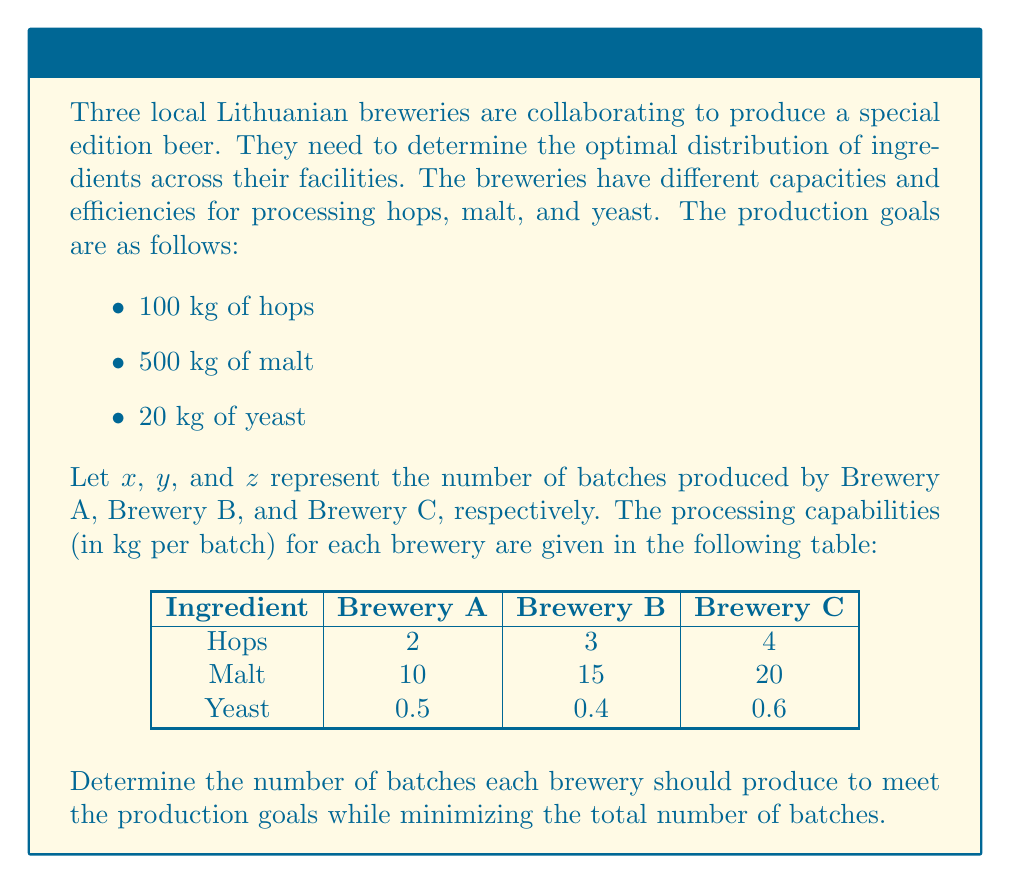Can you solve this math problem? To solve this problem, we need to set up a system of linear equations based on the given information and then solve it.

Step 1: Set up the system of linear equations

For hops: $2x + 3y + 4z = 100$
For malt: $10x + 15y + 20z = 500$
For yeast: $0.5x + 0.4y + 0.6z = 20$

Step 2: Simplify the equations

Equation 1: $2x + 3y + 4z = 100$
Equation 2: $2x + 3y + 4z = 100$ (divide by 5)
Equation 3: $5x + 4y + 6z = 200$ (multiply by 10)

Step 3: Subtract Equation 1 from Equation 2

$0 = 0$

This means Equation 1 and Equation 2 are equivalent, so we can discard one of them.

Step 4: Use Equation 1 and Equation 3 to solve for x and y in terms of z

From Equation 1: $x = 50 - \frac{3}{2}y - 2z$

Substitute this into Equation 3:
$5(50 - \frac{3}{2}y - 2z) + 4y + 6z = 200$
$250 - \frac{15}{2}y - 10z + 4y + 6z = 200$
$250 - \frac{7}{2}y - 4z = 200$
$50 - \frac{7}{2}y - 4z = 0$
$y = \frac{100}{7} - \frac{8}{7}z$

Step 5: Express x in terms of z

$x = 50 - \frac{3}{2}(\frac{100}{7} - \frac{8}{7}z) - 2z$
$x = 50 - \frac{150}{7} + \frac{12}{7}z - 2z$
$x = \frac{200}{7} - \frac{2}{7}z$

Step 6: To minimize the total number of batches, we need to minimize $x + y + z$

$x + y + z = (\frac{200}{7} - \frac{2}{7}z) + (\frac{100}{7} - \frac{8}{7}z) + z$
$= \frac{300}{7} - \frac{3}{7}z$

This expression is minimized when z is at its maximum possible value.

Step 7: Find the maximum value for z

Since x, y, and z must be non-negative:

$\frac{200}{7} - \frac{2}{7}z \geq 0$
$z \leq 100$

$\frac{100}{7} - \frac{8}{7}z \geq 0$
$z \leq \frac{25}{2}$

Therefore, the maximum value for z is 12.5.

Step 8: Calculate x and y

$x = \frac{200}{7} - \frac{2}{7}(12.5) = 25$
$y = \frac{100}{7} - \frac{8}{7}(12.5) = 0$

Step 9: Round the values to the nearest whole number

x = 25
y = 0
z = 13
Answer: Brewery A: 25 batches, Brewery B: 0 batches, Brewery C: 13 batches 